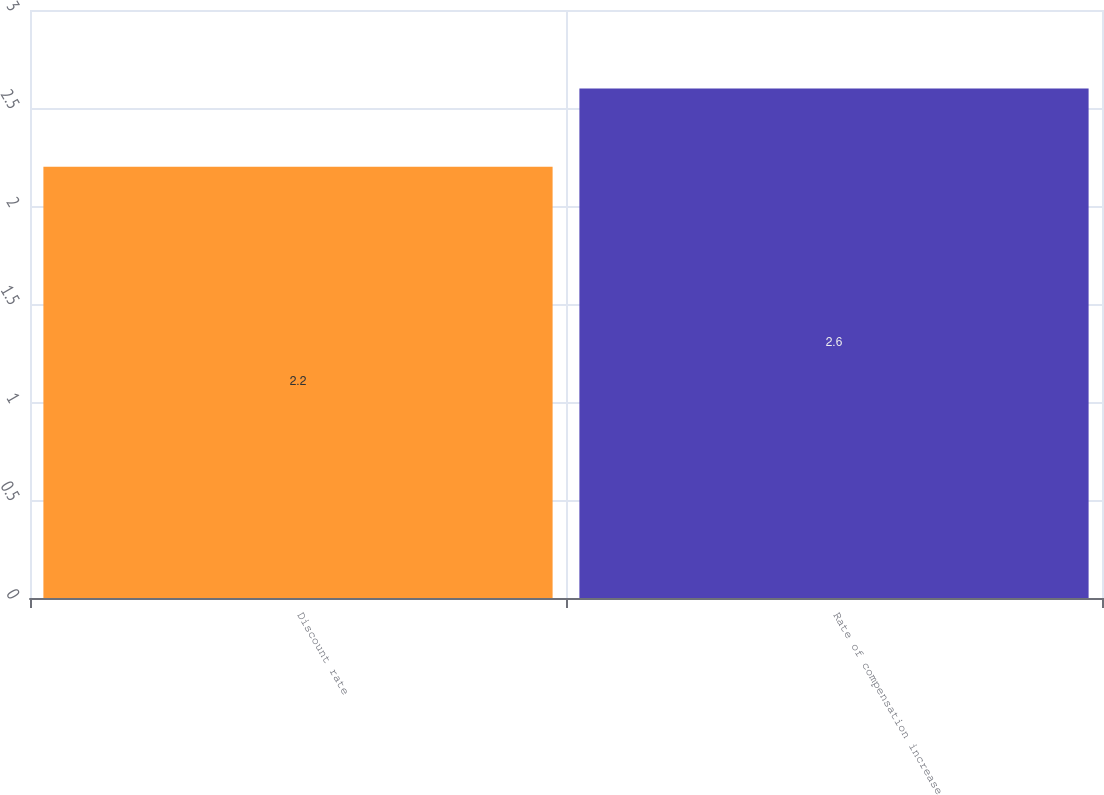<chart> <loc_0><loc_0><loc_500><loc_500><bar_chart><fcel>Discount rate<fcel>Rate of compensation increase<nl><fcel>2.2<fcel>2.6<nl></chart> 